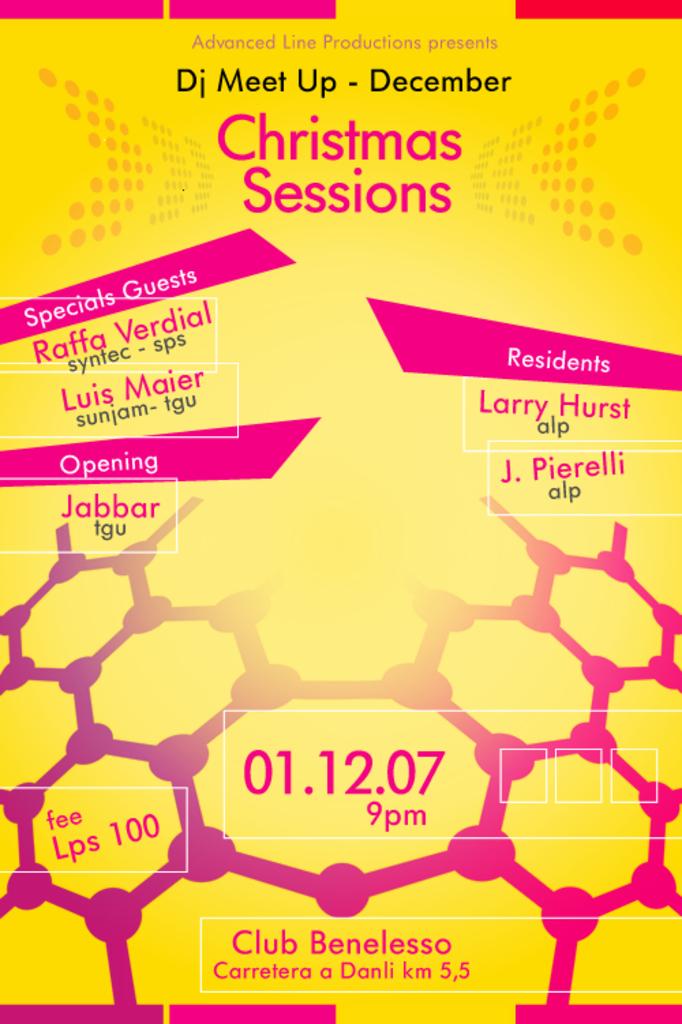What month is the event happening?
Your answer should be compact. December. 